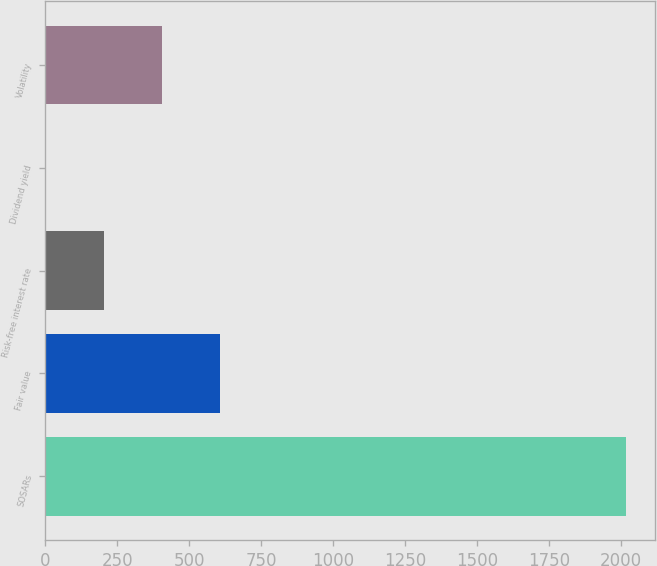Convert chart. <chart><loc_0><loc_0><loc_500><loc_500><bar_chart><fcel>SOSARs<fcel>Fair value<fcel>Risk-free interest rate<fcel>Dividend yield<fcel>Volatility<nl><fcel>2018<fcel>606.37<fcel>203.05<fcel>1.39<fcel>404.71<nl></chart> 